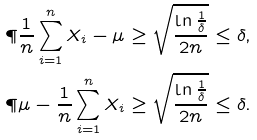Convert formula to latex. <formula><loc_0><loc_0><loc_500><loc_500>\P { \frac { 1 } { n } \sum _ { i = 1 } ^ { n } X _ { i } - \mu \geq \sqrt { \frac { \ln \frac { 1 } { \delta } } { 2 n } } } & \leq \delta , \\ \P { \mu - \frac { 1 } { n } \sum _ { i = 1 } ^ { n } X _ { i } \geq \sqrt { \frac { \ln \frac { 1 } { \delta } } { 2 n } } } & \leq \delta .</formula> 